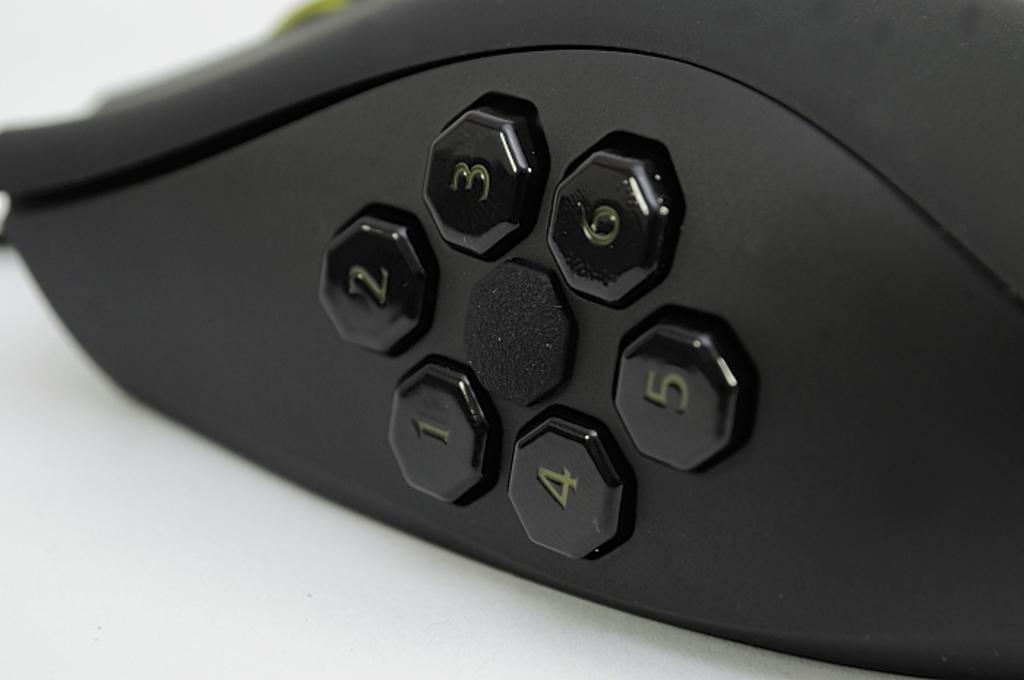Please provide a concise description of this image. In this image, we can see a device on the ground. 